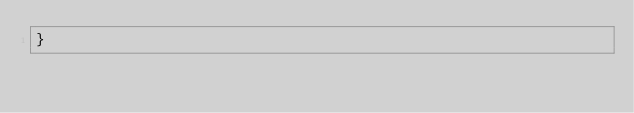<code> <loc_0><loc_0><loc_500><loc_500><_Kotlin_>}
</code> 